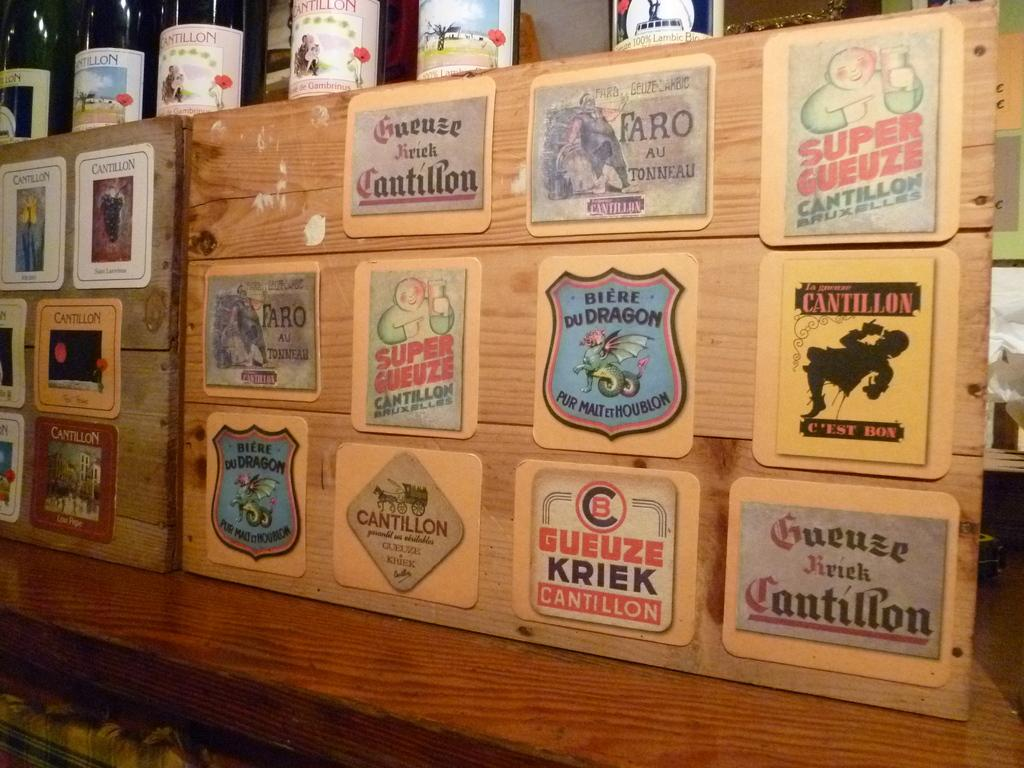What is attached to the wood in the image? There are boards pasted on wood in the image. What objects can be seen at the top of the image? There are bottles at the top of the image. Is there a cactus growing in the middle of the bottles in the image? There is no cactus present in the image; it only features boards pasted on wood and bottles. How does the temper of the person who arranged the bottles in the image affect the arrangement? The temper of the person who arranged the bottles in the image is not mentioned or depicted, so it cannot be determined how it might affect the arrangement. 